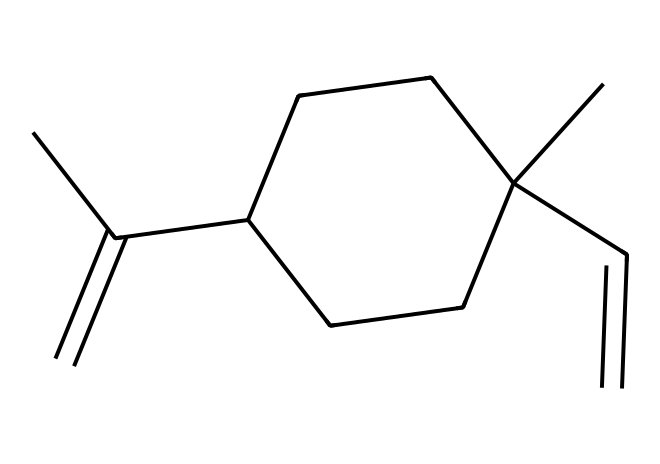What is the molecular formula of R-limonene? To determine the molecular formula, count the number of carbon (C) and hydrogen (H) atoms in the structure. The structure has 10 carbon atoms and 16 hydrogen atoms. Therefore, the molecular formula is C10H16.
Answer: C10H16 How many stereocenters are present in R-limonene? A stereocenter is typically a carbon atom connected to four different substituents. By analyzing the structure, we find two carbon atoms that meet this criterion. Thus, there are two stereocenters in R-limonene.
Answer: 2 What type of compound is R-limonene? R-limonene is categorized as a terpene, which is a class of compounds derived from isoprene units. Given its structure, it is specifically recognized as a monoterpene because it contains two isoprene units.
Answer: monoterpene Which specific chiral feature does R-limonene possess? The specific chiral feature in R-limonene is the arrangement around one of its stereocenters, leading to non-superimposable mirror images (enantiomers). This chirality gives it unique properties such as flavor and aroma in citrus beverages.
Answer: chirality How does the presence of double bonds affect the reactivity of R-limonene? The presence of double bonds in R-limonene increases its reactivity due to the availability of π electrons, which can participate in various reactions, such as electrophilic addition. This makes it more reactive compared to saturated hydrocarbons.
Answer: increases reactivity What role does R-limonene play in citrus-flavored drinks? R-limonene serves as a flavoring and aromatic agent in citrus-flavored drinks, providing a fresh and zesty odor that is characteristic of citrus fruits. Its unique properties make it popular in flavor formulations.
Answer: flavoring agent 